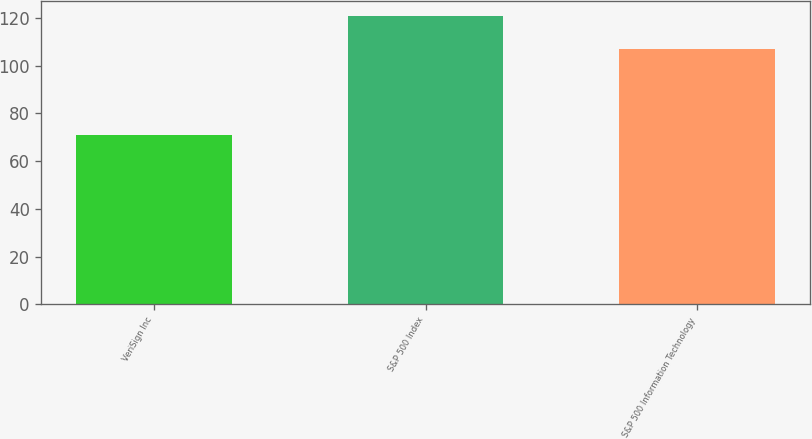Convert chart. <chart><loc_0><loc_0><loc_500><loc_500><bar_chart><fcel>VeriSign Inc<fcel>S&P 500 Index<fcel>S&P 500 Information Technology<nl><fcel>71<fcel>121<fcel>107<nl></chart> 